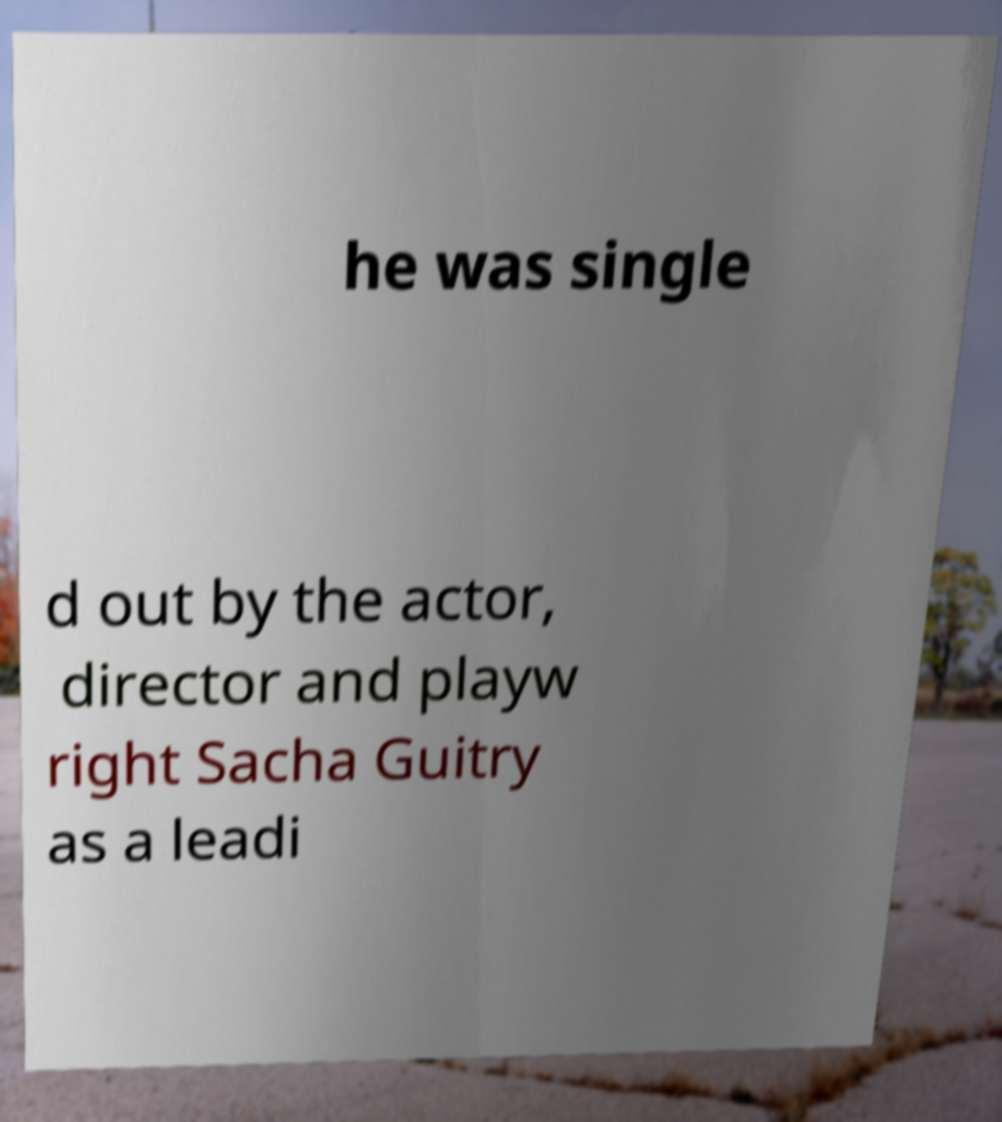Could you assist in decoding the text presented in this image and type it out clearly? he was single d out by the actor, director and playw right Sacha Guitry as a leadi 